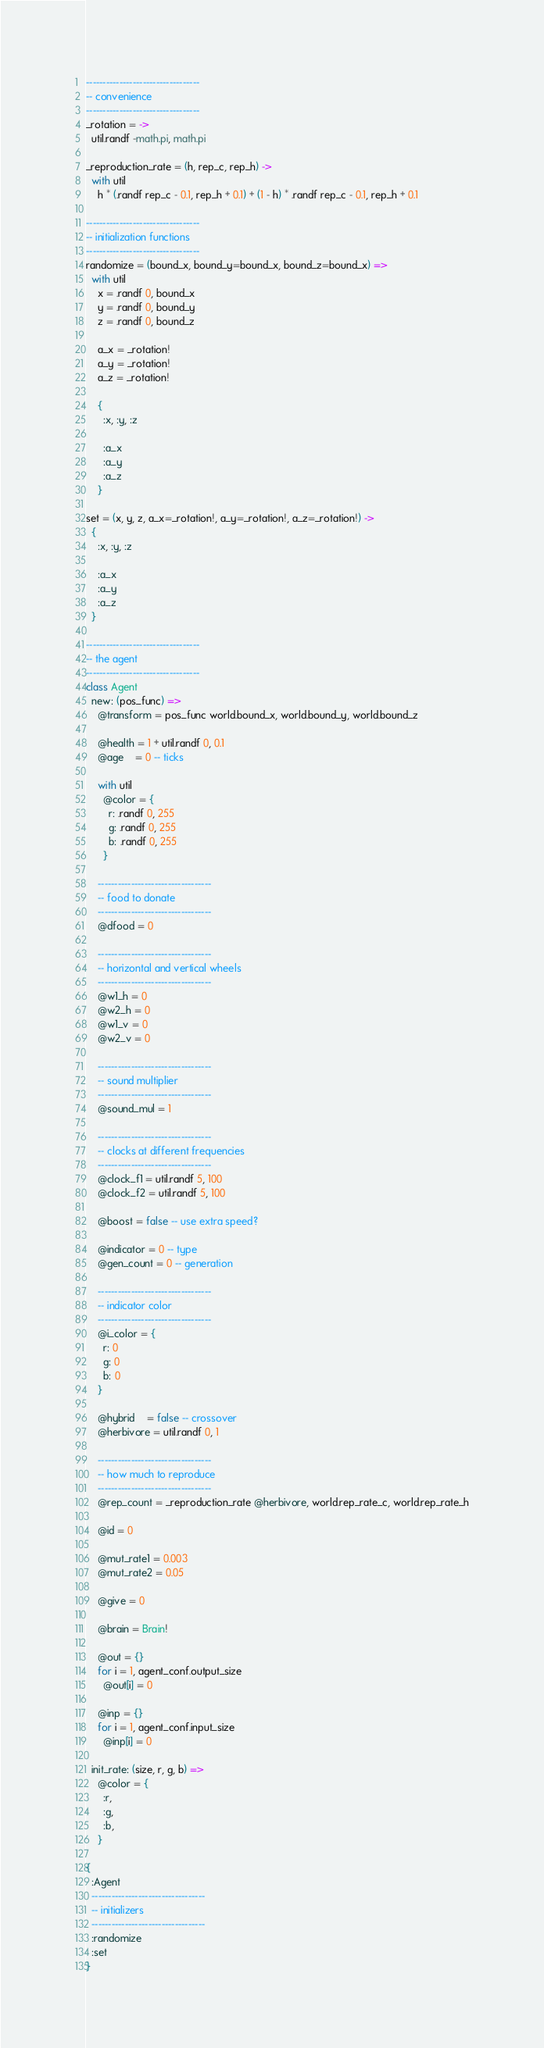Convert code to text. <code><loc_0><loc_0><loc_500><loc_500><_MoonScript_>----------------------------------
-- convenience
----------------------------------
_rotation = ->
  util.randf -math.pi, math.pi

_reproduction_rate = (h, rep_c, rep_h) ->
  with util
    h * (.randf rep_c - 0.1, rep_h + 0.1) + (1 - h) * .randf rep_c - 0.1, rep_h + 0.1

----------------------------------
-- initialization functions
----------------------------------
randomize = (bound_x, bound_y=bound_x, bound_z=bound_x) =>
  with util
    x = .randf 0, bound_x
    y = .randf 0, bound_y
    z = .randf 0, bound_z

    a_x = _rotation!
    a_y = _rotation!
    a_z = _rotation!

    {
      :x, :y, :z

      :a_x
      :a_y
      :a_z
    }

set = (x, y, z, a_x=_rotation!, a_y=_rotation!, a_z=_rotation!) ->
  {
    :x, :y, :z

    :a_x
    :a_y
    :a_z
  }

----------------------------------
-- the agent
----------------------------------
class Agent
  new: (pos_func) =>
    @transform = pos_func world.bound_x, world.bound_y, world.bound_z

    @health = 1 + util.randf 0, 0.1
    @age    = 0 -- ticks

    with util
      @color = {
        r: .randf 0, 255
        g: .randf 0, 255
        b: .randf 0, 255
      }

    ----------------------------------
    -- food to donate
    ----------------------------------
    @dfood = 0

    ----------------------------------
    -- horizontal and vertical wheels
    ----------------------------------
    @w1_h = 0
    @w2_h = 0
    @w1_v = 0
    @w2_v = 0

    ----------------------------------
    -- sound multiplier
    ----------------------------------
    @sound_mul = 1

    ----------------------------------
    -- clocks at different frequencies
    ----------------------------------
    @clock_f1 = util.randf 5, 100
    @clock_f2 = util.randf 5, 100

    @boost = false -- use extra speed?

    @indicator = 0 -- type
    @gen_count = 0 -- generation

    ----------------------------------
    -- indicator color
    ----------------------------------
    @i_color = {
      r: 0
      g: 0
      b: 0
    }

    @hybrid    = false -- crossover
    @herbivore = util.randf 0, 1

    ----------------------------------
    -- how much to reproduce
    ----------------------------------
    @rep_count = _reproduction_rate @herbivore, world.rep_rate_c, world.rep_rate_h

    @id = 0

    @mut_rate1 = 0.003
    @mut_rate2 = 0.05

    @give = 0

    @brain = Brain!

    @out = {}
    for i = 1, agent_conf.output_size
      @out[i] = 0

    @inp = {}
    for i = 1, agent_conf.input_size
      @inp[i] = 0

  init_rate: (size, r, g, b) =>
    @color = {
      :r,
      :g,
      :b,
    }

{
  :Agent
  ----------------------------------
  -- initializers
  ----------------------------------
  :randomize
  :set
}
</code> 